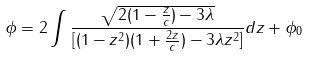<formula> <loc_0><loc_0><loc_500><loc_500>\phi = 2 \int \frac { \sqrt { 2 ( 1 - \frac { z } { c } ) - 3 \lambda } } { [ ( 1 - z ^ { 2 } ) ( 1 + \frac { 2 z } { c } ) - 3 \lambda z ^ { 2 } ] } d z + \phi _ { 0 }</formula> 